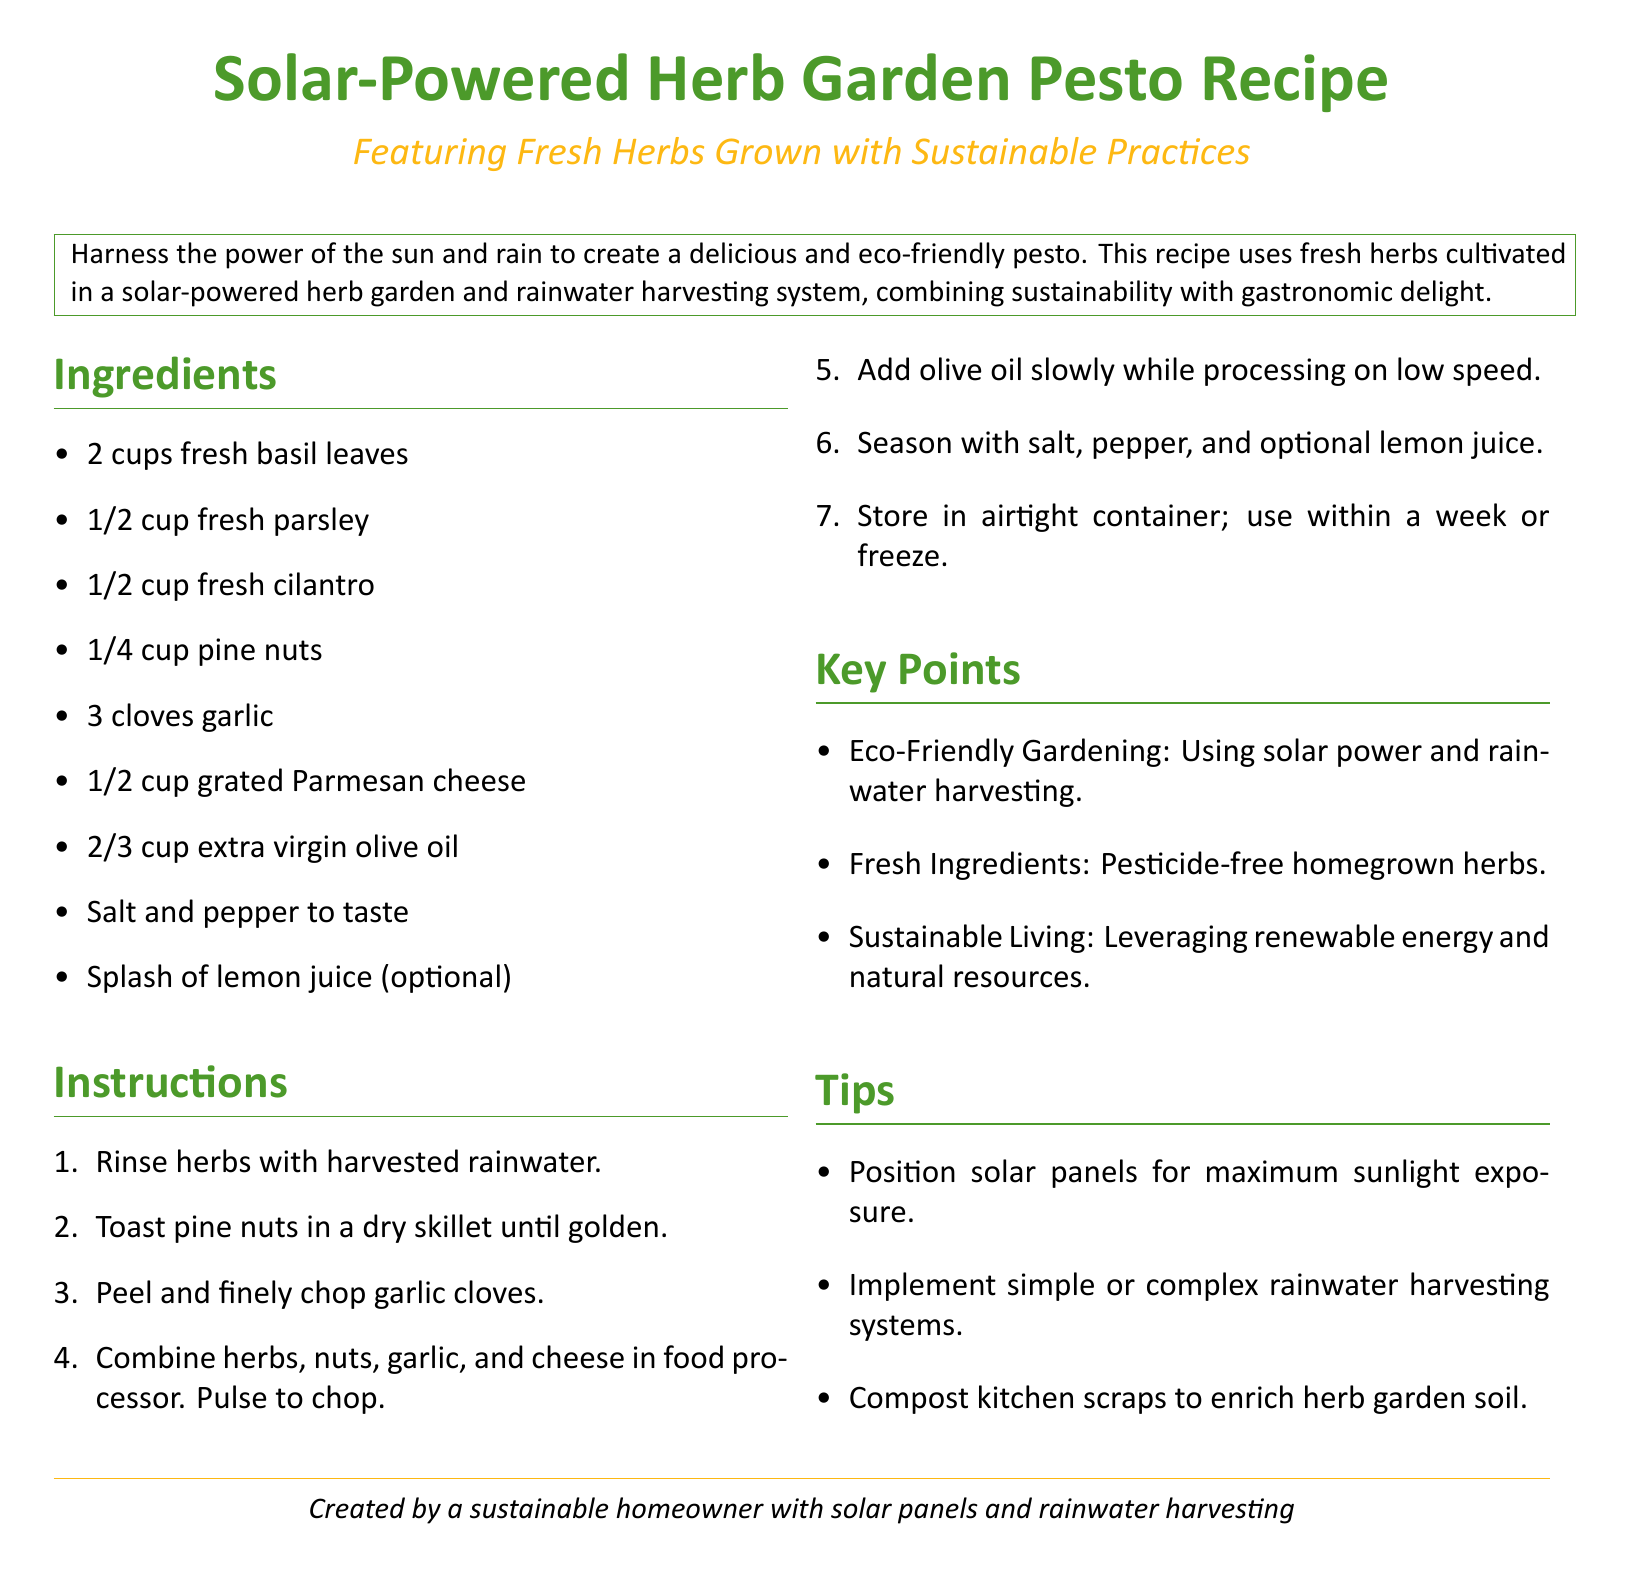What is the main ingredient in the pesto? The main ingredient in the pesto, as listed in the ingredients section, is fresh basil leaves.
Answer: fresh basil leaves How many cloves of garlic are needed? The recipe specifies the use of 3 cloves of garlic in the ingredients section.
Answer: 3 cloves What type of cheese is used in the recipe? The ingredients state that 1/2 cup of grated Parmesan cheese is used in the pesto.
Answer: Parmesan cheese How many cups of fresh herbs are in the recipe? The total amount of fresh herbs mentioned in the ingredients is 2 cups of basil, 1/2 cup parsley, and 1/2 cup cilantro, totaling 3 cups.
Answer: 3 cups What is an optional ingredient for the pesto? The recipe includes a splash of lemon juice as an optional ingredient.
Answer: splash of lemon juice What system is used for watering the herbs? The instructions state that the herbs are rinsed with harvested rainwater, indicating a specific watering system.
Answer: harvested rainwater What is one key point about the gardening practices? The document highlights eco-friendly gardening as a key point, emphasizing the use of solar power and rainwater harvesting.
Answer: Eco-Friendly Gardening What should you do with kitchen scraps? The tips suggest composting kitchen scraps to enrich the herb garden soil.
Answer: compost kitchen scraps 